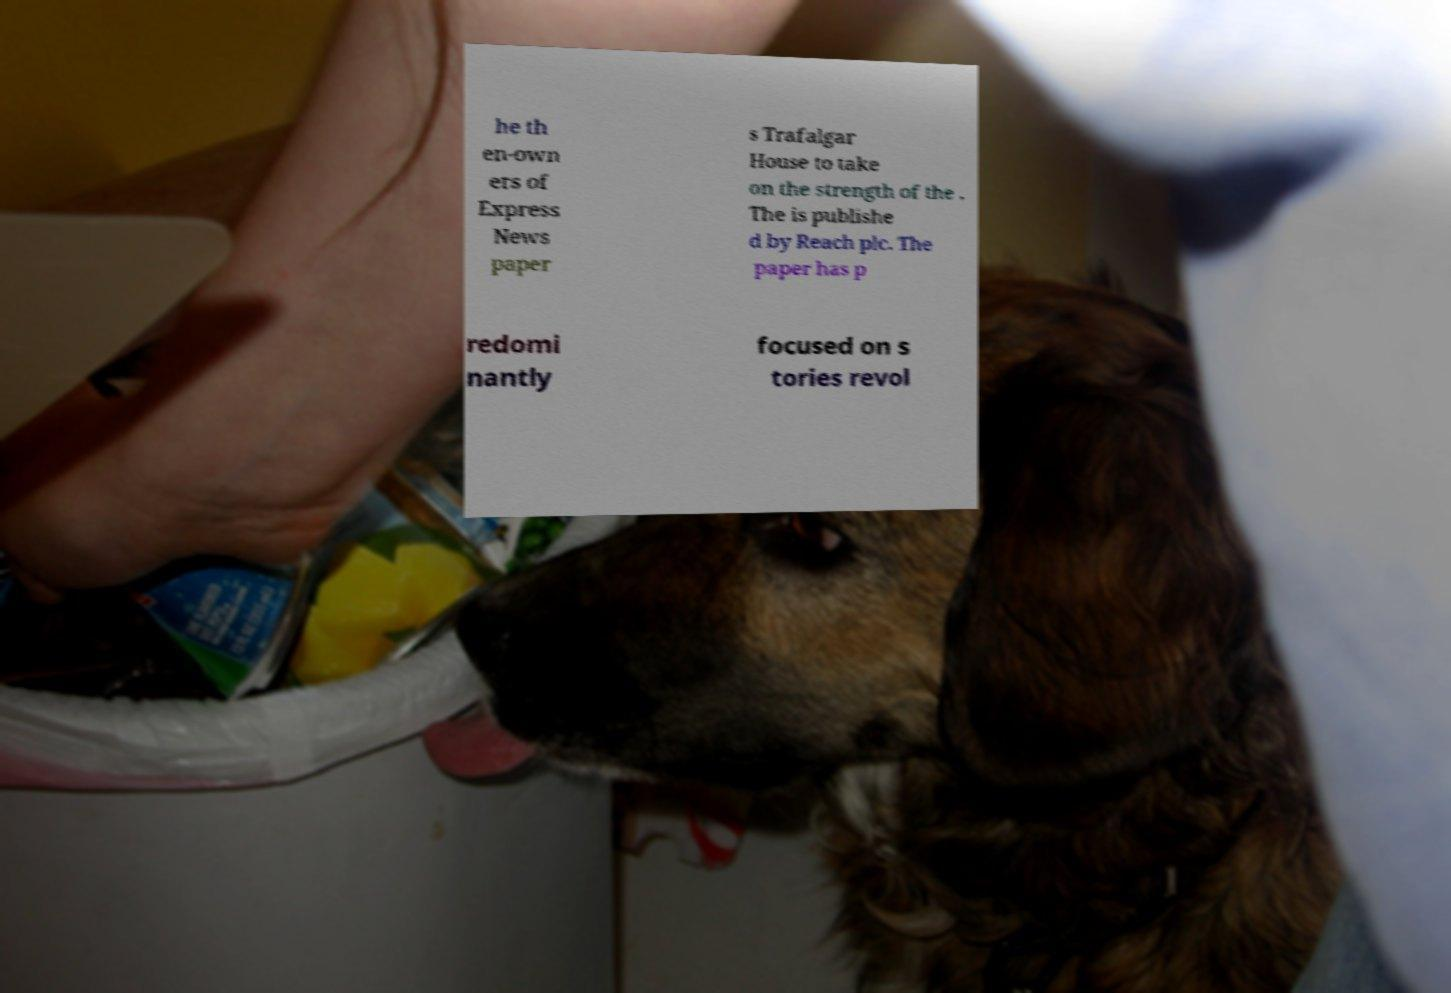Could you assist in decoding the text presented in this image and type it out clearly? he th en-own ers of Express News paper s Trafalgar House to take on the strength of the . The is publishe d by Reach plc. The paper has p redomi nantly focused on s tories revol 